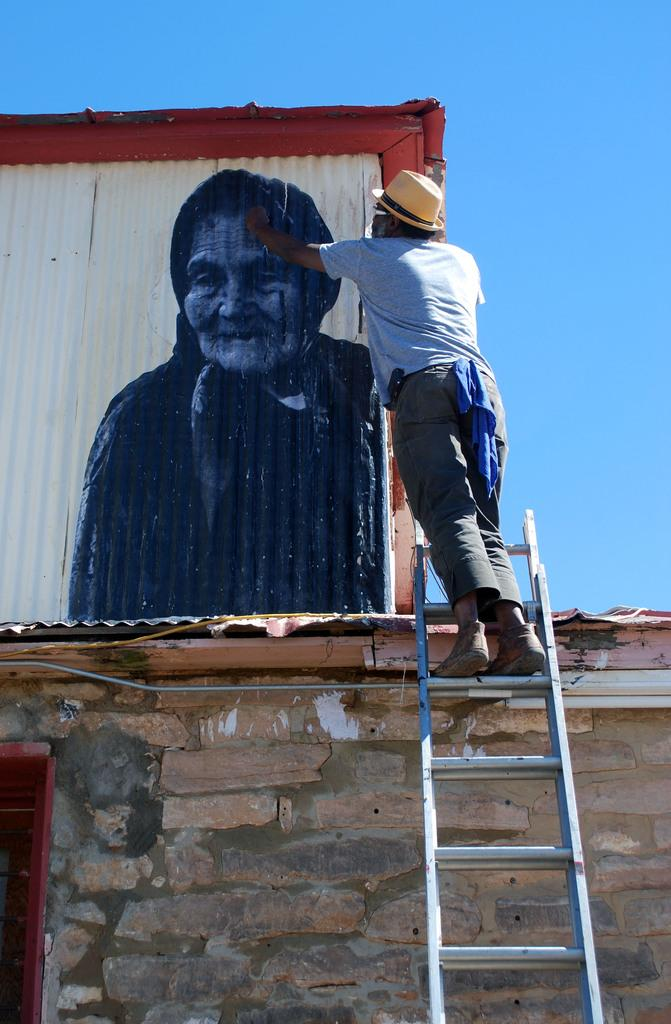What is the man in the image doing? The man is standing on a ladder and painting on a board. Where is the man located in the image? The man is standing on a ladder. What is visible at the bottom of the image? There is a wall at the bottom of the image. What can be seen in the background of the image? The sky is visible in the background of the image. What type of gold is the man using to paint in the image? There is no mention of gold in the image. The man is using a paintbrush and a board to paint. 